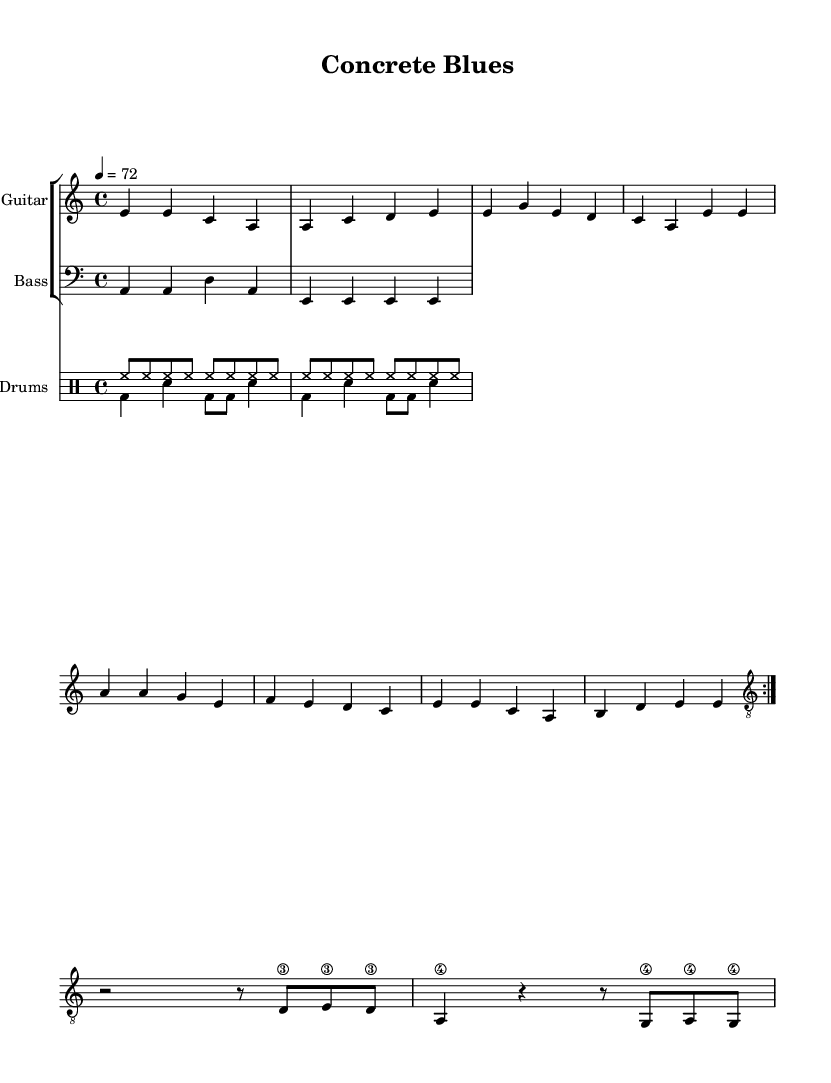What is the key signature of this music? The key signature indicated in the sheet music is A minor, which consists of no sharps or flats.
Answer: A minor What is the time signature of this music? The time signature shown in the sheet music is 4/4, meaning there are four beats in each measure and the quarter note gets one beat.
Answer: 4/4 What is the tempo marking of this music? The tempo marking states "4 = 72", indicating that there are 72 beats per minute, using quarter notes as the unit of measurement.
Answer: 72 How many times is the verse repeated? The score shows that the verse is repeated twice, indicated by the repeat volta markings before the verse.
Answer: Twice What instruments are included in this arrangement? The sheet music specifies three instruments: Guitar, Bass, and Drums, as indicated by their respective staves and instrument names.
Answer: Guitar, Bass, Drums What is the lyrical theme of the chorus? The chorus expresses a feeling of loss related to the community, with the lyrics referencing "losing our home" reflecting on the changes in local character.
Answer: Losing our home What character of the music is indicated by the term "blues" in the title? The term "blues" in the title suggests a soulful, melancholic quality, which is a hallmark of the blues genre, often reflecting emotional struggles and social issues.
Answer: Soulful 